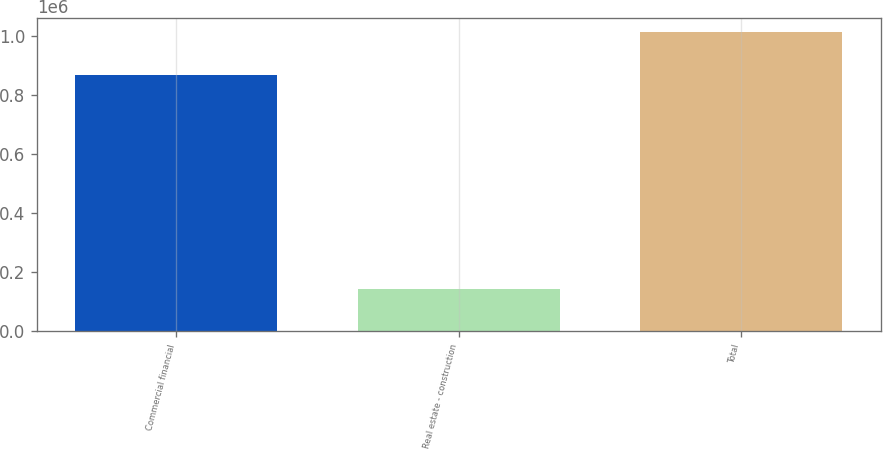Convert chart. <chart><loc_0><loc_0><loc_500><loc_500><bar_chart><fcel>Commercial financial<fcel>Real estate - construction<fcel>Total<nl><fcel>867810<fcel>144739<fcel>1.01255e+06<nl></chart> 